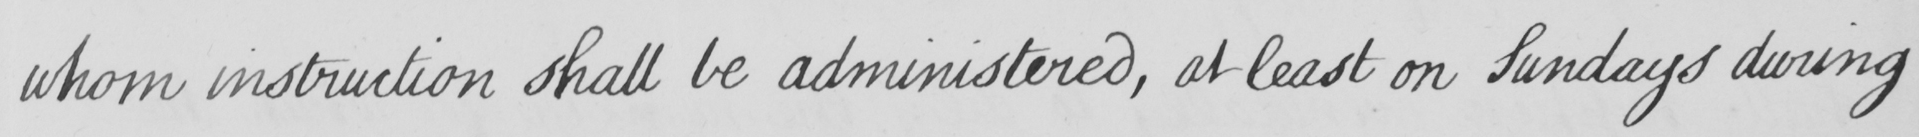What does this handwritten line say? whom instruction shall be administered , at least on Sundays during 